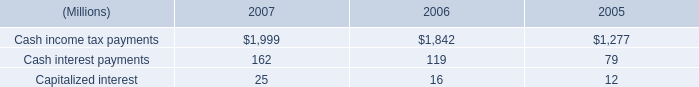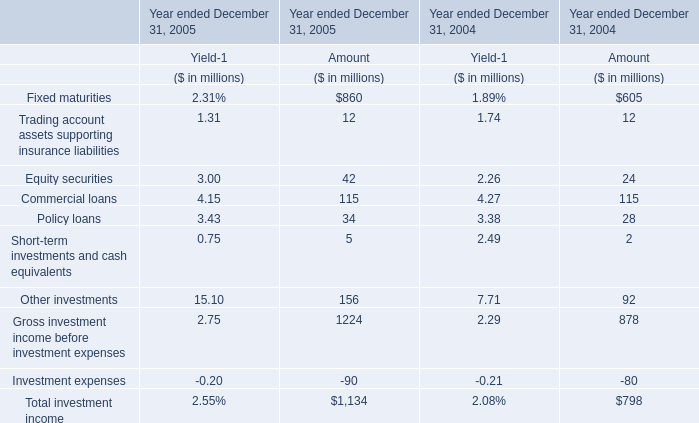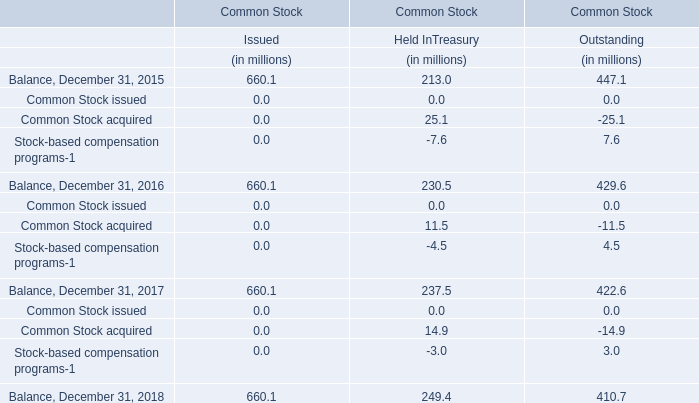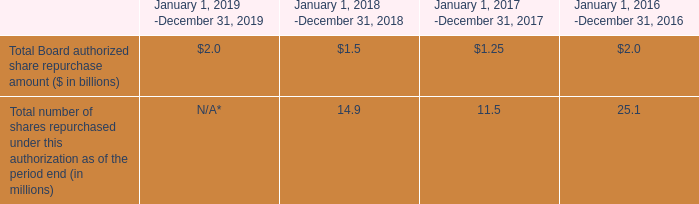Which year is Other investments greater than 100 ? 
Answer: 2005. 